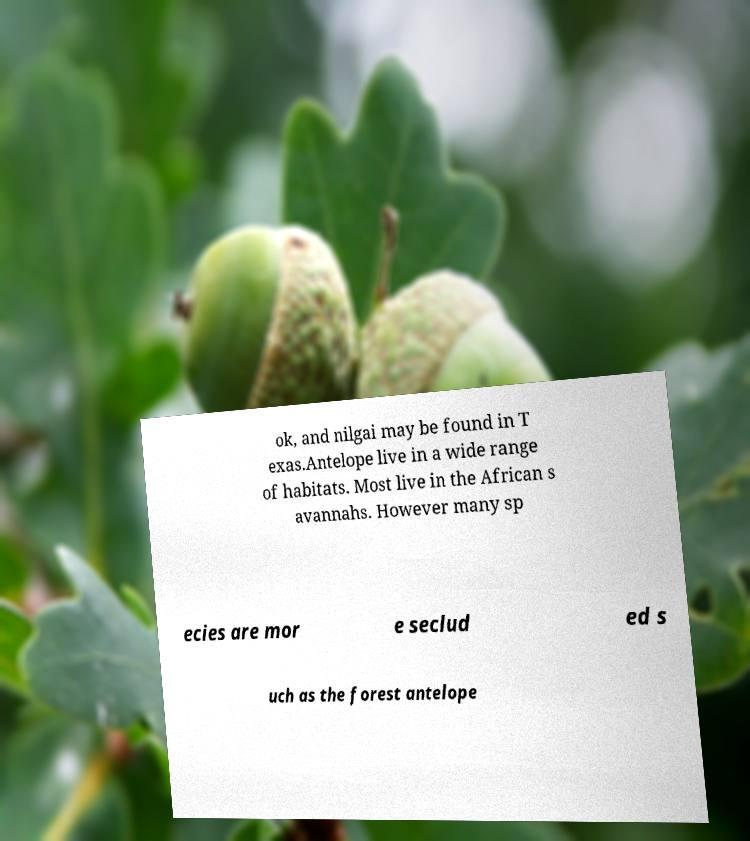For documentation purposes, I need the text within this image transcribed. Could you provide that? ok, and nilgai may be found in T exas.Antelope live in a wide range of habitats. Most live in the African s avannahs. However many sp ecies are mor e seclud ed s uch as the forest antelope 